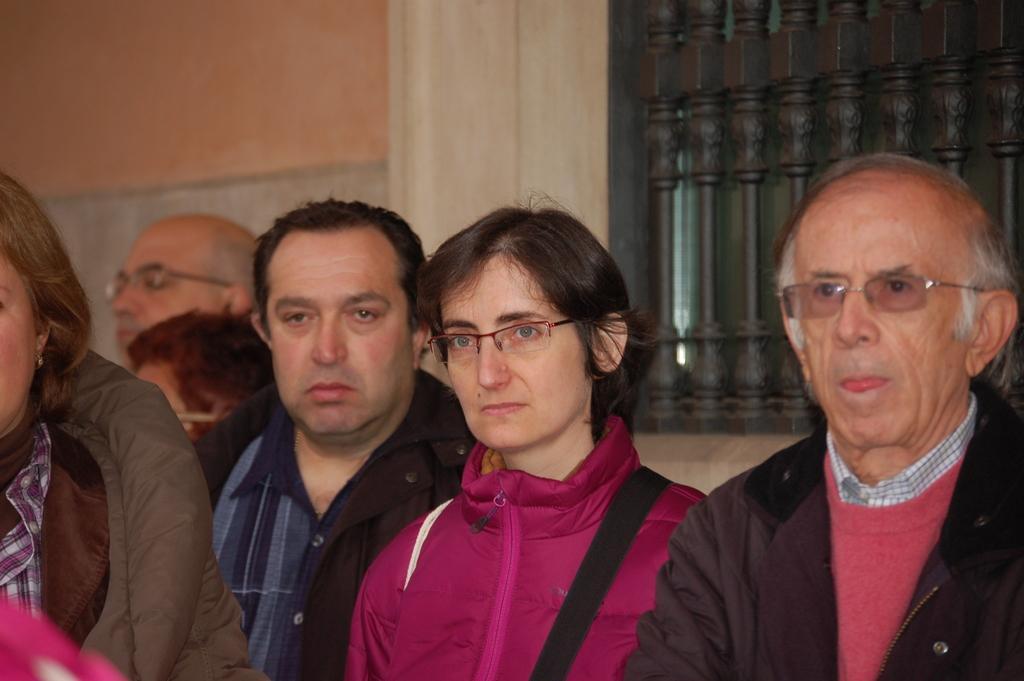Describe this image in one or two sentences. In this image there are group of people some of them are wearing spectacles, and in the background there is a wall and railing. 